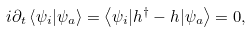<formula> <loc_0><loc_0><loc_500><loc_500>i \partial _ { t } \left \langle \psi _ { i } | \psi _ { a } \right \rangle = \left \langle \psi _ { i } | h ^ { \dagger } - h | \psi _ { a } \right \rangle = 0 ,</formula> 